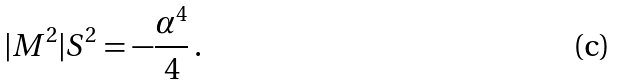Convert formula to latex. <formula><loc_0><loc_0><loc_500><loc_500>| M ^ { 2 } | S ^ { 2 } = - \frac { \alpha ^ { 4 } } { 4 } \, .</formula> 